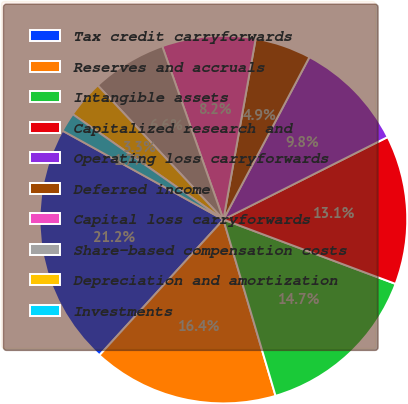Convert chart to OTSL. <chart><loc_0><loc_0><loc_500><loc_500><pie_chart><fcel>Tax credit carryforwards<fcel>Reserves and accruals<fcel>Intangible assets<fcel>Capitalized research and<fcel>Operating loss carryforwards<fcel>Deferred income<fcel>Capital loss carryforwards<fcel>Share-based compensation costs<fcel>Depreciation and amortization<fcel>Investments<nl><fcel>21.25%<fcel>16.36%<fcel>14.73%<fcel>13.1%<fcel>9.84%<fcel>4.94%<fcel>8.21%<fcel>6.58%<fcel>3.31%<fcel>1.68%<nl></chart> 